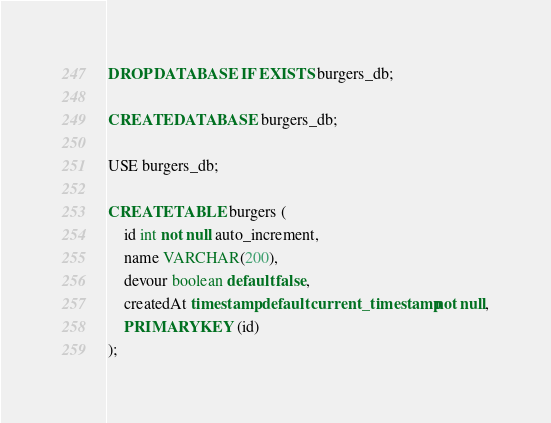Convert code to text. <code><loc_0><loc_0><loc_500><loc_500><_SQL_>DROP DATABASE IF EXISTS burgers_db;

CREATE DATABASE burgers_db;

USE burgers_db;

CREATE TABLE burgers (
    id int not null auto_increment,
    name VARCHAR(200),
    devour boolean default false,
    createdAt timestamp default current_timestamp not null,
    PRIMARY KEY (id)
);</code> 